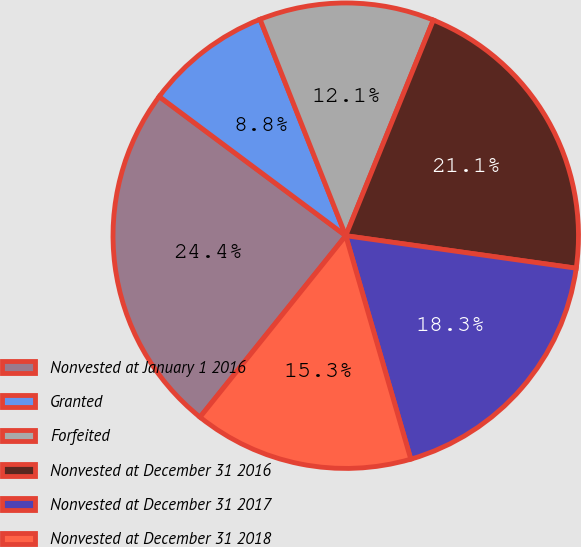Convert chart to OTSL. <chart><loc_0><loc_0><loc_500><loc_500><pie_chart><fcel>Nonvested at January 1 2016<fcel>Granted<fcel>Forfeited<fcel>Nonvested at December 31 2016<fcel>Nonvested at December 31 2017<fcel>Nonvested at December 31 2018<nl><fcel>24.43%<fcel>8.8%<fcel>12.14%<fcel>21.09%<fcel>18.26%<fcel>15.28%<nl></chart> 